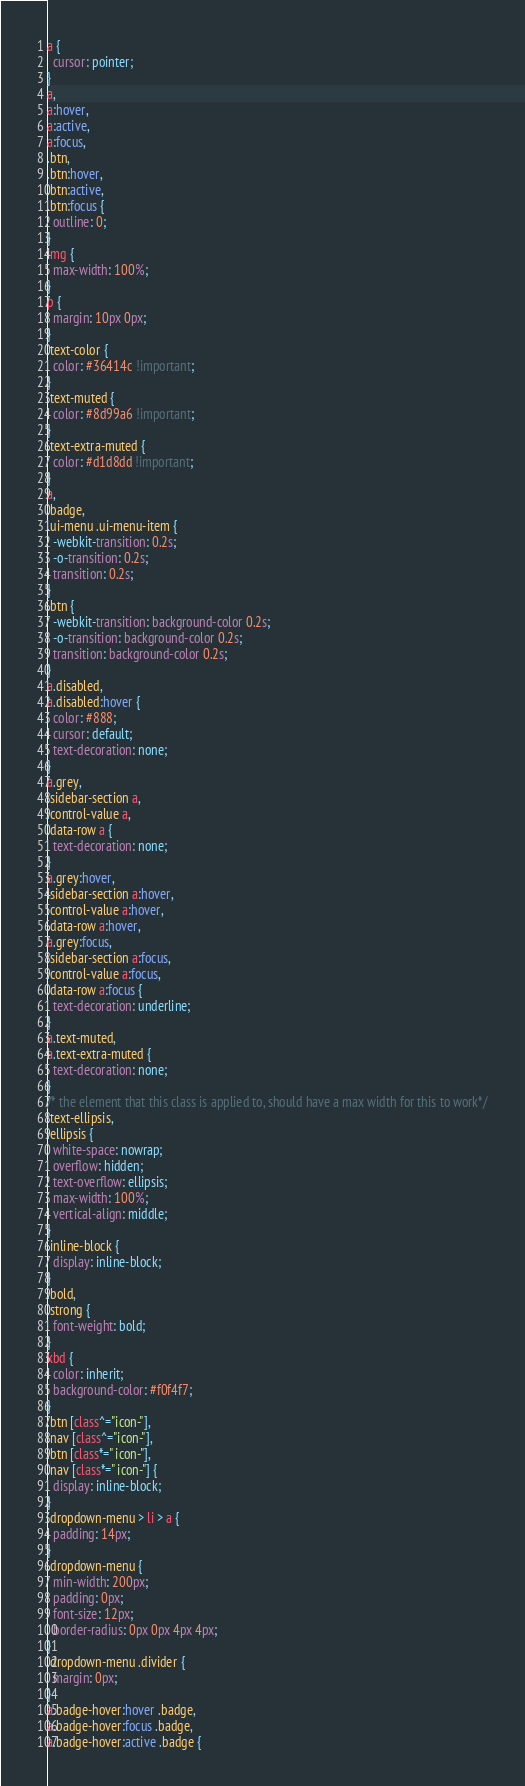Convert code to text. <code><loc_0><loc_0><loc_500><loc_500><_CSS_>a {
  cursor: pointer;
}
a,
a:hover,
a:active,
a:focus,
.btn,
.btn:hover,
.btn:active,
.btn:focus {
  outline: 0;
}
img {
  max-width: 100%;
}
p {
  margin: 10px 0px;
}
.text-color {
  color: #36414c !important;
}
.text-muted {
  color: #8d99a6 !important;
}
.text-extra-muted {
  color: #d1d8dd !important;
}
a,
.badge,
.ui-menu .ui-menu-item {
  -webkit-transition: 0.2s;
  -o-transition: 0.2s;
  transition: 0.2s;
}
.btn {
  -webkit-transition: background-color 0.2s;
  -o-transition: background-color 0.2s;
  transition: background-color 0.2s;
}
a.disabled,
a.disabled:hover {
  color: #888;
  cursor: default;
  text-decoration: none;
}
a.grey,
.sidebar-section a,
.control-value a,
.data-row a {
  text-decoration: none;
}
a.grey:hover,
.sidebar-section a:hover,
.control-value a:hover,
.data-row a:hover,
a.grey:focus,
.sidebar-section a:focus,
.control-value a:focus,
.data-row a:focus {
  text-decoration: underline;
}
a.text-muted,
a.text-extra-muted {
  text-decoration: none;
}
/* the element that this class is applied to, should have a max width for this to work*/
.text-ellipsis,
.ellipsis {
  white-space: nowrap;
  overflow: hidden;
  text-overflow: ellipsis;
  max-width: 100%;
  vertical-align: middle;
}
.inline-block {
  display: inline-block;
}
.bold,
.strong {
  font-weight: bold;
}
kbd {
  color: inherit;
  background-color: #f0f4f7;
}
.btn [class^="icon-"],
.nav [class^="icon-"],
.btn [class*=" icon-"],
.nav [class*=" icon-"] {
  display: inline-block;
}
.dropdown-menu > li > a {
  padding: 14px;
}
.dropdown-menu {
  min-width: 200px;
  padding: 0px;
  font-size: 12px;
  border-radius: 0px 0px 4px 4px;
}
.dropdown-menu .divider {
  margin: 0px;
}
a.badge-hover:hover .badge,
a.badge-hover:focus .badge,
a.badge-hover:active .badge {</code> 